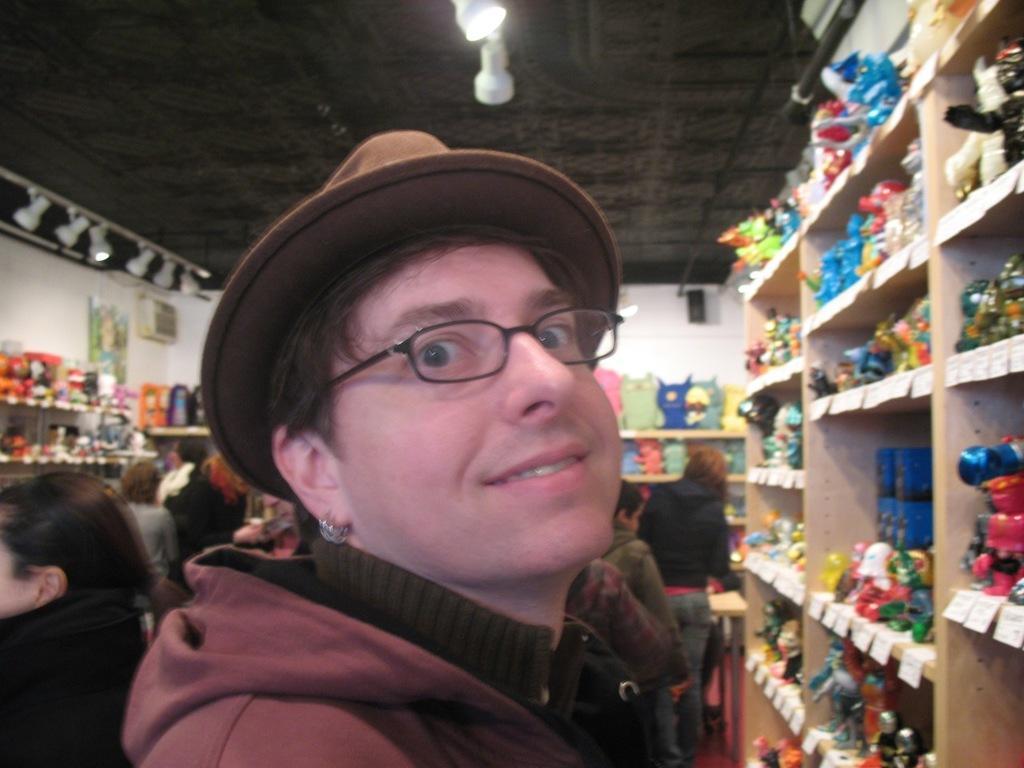Could you give a brief overview of what you see in this image? In the center of the image we can see a person wearing a hat. On the right there is a shelf and we can see goods placed in the shelf. In the background there is a wall. At the top is light and we can see people. 